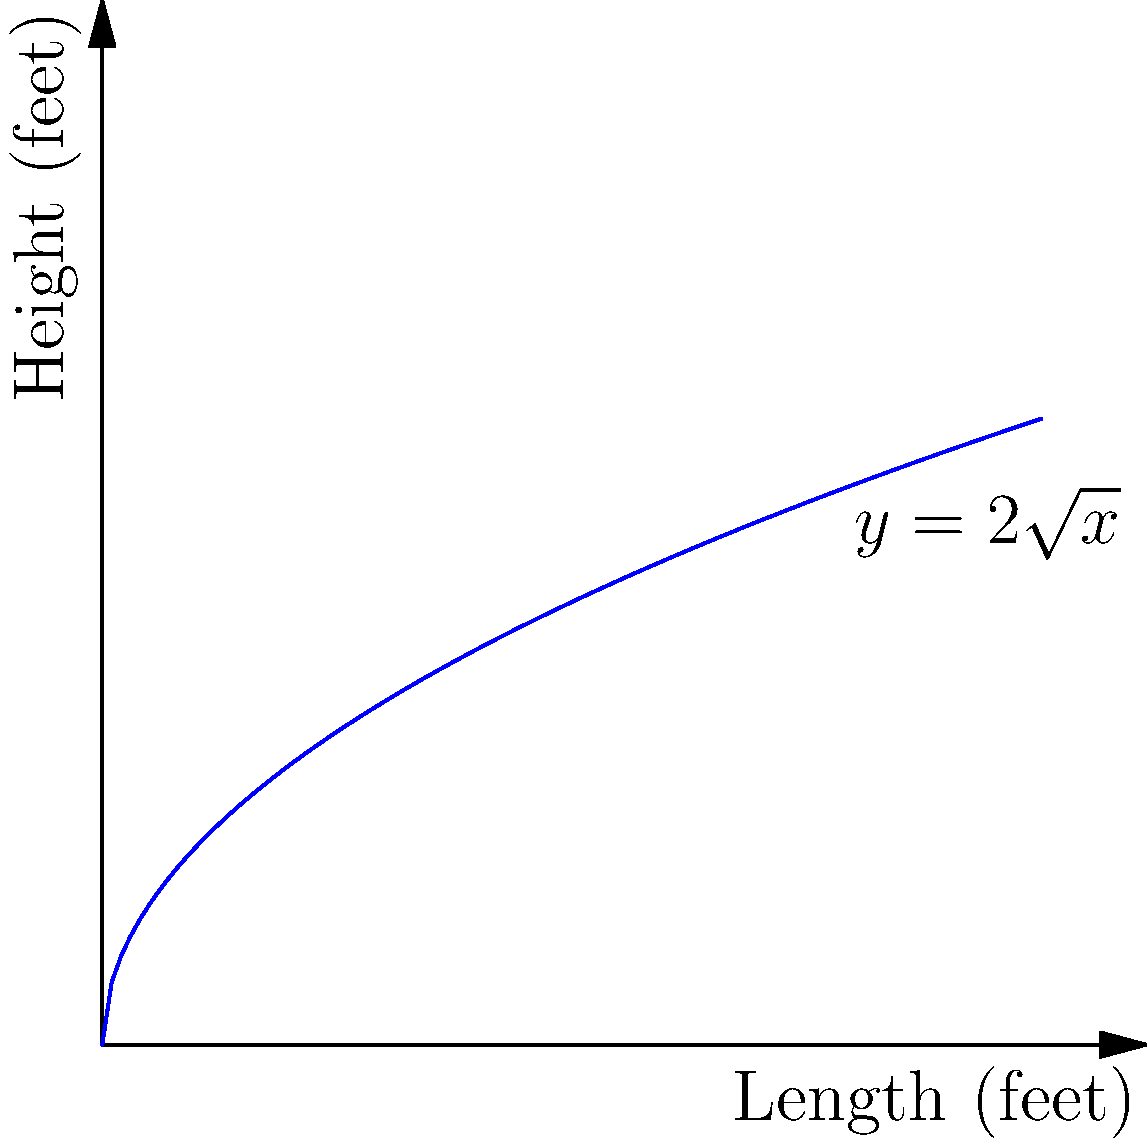As a supply chain manager, you're tasked with optimizing shipping container space. The cross-section of a new container design follows the curve $y=2\sqrt{x}$, where $x$ is the length and $y$ is the height in feet. If the container is 9 feet long, what is the volume of the largest rectangular box that can fit inside this container, assuming the box spans the entire width of the container? To solve this problem, we'll follow these steps:

1) The volume of the box is given by $V = x * y * w$, where $w$ is the width of the container (constant).

2) We need to maximize $V = x * y$, where $y \leq 2\sqrt{x}$ and $0 \leq x \leq 9$.

3) At the optimal point, the top of the box will touch the curve, so $y = 2\sqrt{x}$.

4) Substituting this into our volume equation:
   $V = x * 2\sqrt{x} * w = 2x\sqrt{x} * w = 2x^{3/2} * w$

5) To find the maximum, we differentiate $V$ with respect to $x$ and set it to zero:
   $\frac{dV}{dx} = 2w * \frac{3}{2}x^{1/2} = 3wx^{1/2}$
   $3wx^{1/2} = 0$
   $x^{1/2} = 0$
   $x = 0$ (which is not in our domain)

6) Since there's no critical point in our domain, the maximum must occur at one of the endpoints. We check $x=0$ and $x=9$:
   At $x=0$: $V = 0$
   At $x=9$: $V = 2(9)^{3/2} * w = 54w$

7) Therefore, the maximum volume occurs when $x=9$ and $y=2\sqrt{9}=6$.

8) The volume of the largest rectangular box is thus $9 * 6 * w = 54w$ cubic feet.
Answer: $54w$ cubic feet 